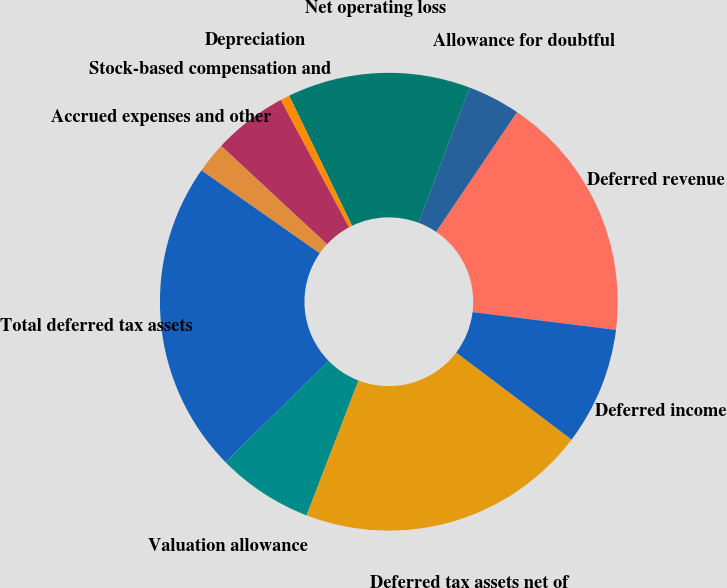Convert chart to OTSL. <chart><loc_0><loc_0><loc_500><loc_500><pie_chart><fcel>Deferred revenue<fcel>Allowance for doubtful<fcel>Net operating loss<fcel>Depreciation<fcel>Stock-based compensation and<fcel>Accrued expenses and other<fcel>Total deferred tax assets<fcel>Valuation allowance<fcel>Deferred tax assets net of<fcel>Deferred income<nl><fcel>17.5%<fcel>3.72%<fcel>12.91%<fcel>0.66%<fcel>5.25%<fcel>2.19%<fcel>22.09%<fcel>6.79%<fcel>20.56%<fcel>8.32%<nl></chart> 